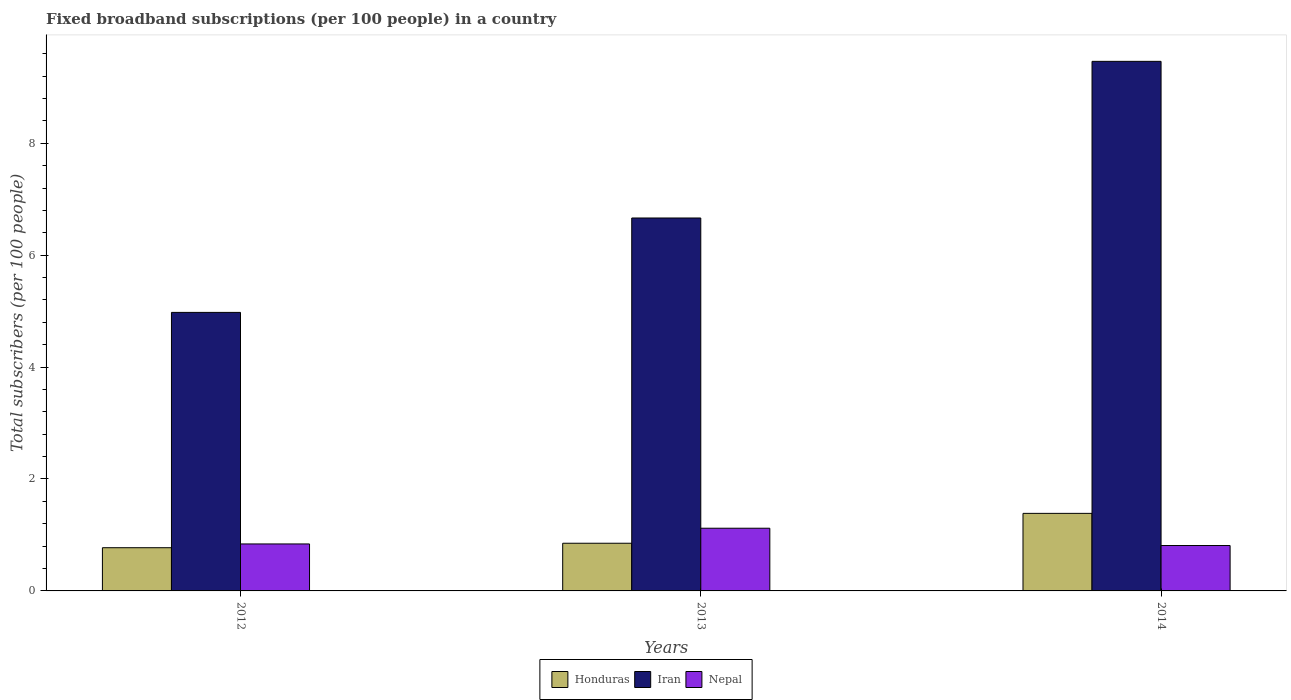How many groups of bars are there?
Offer a very short reply. 3. Are the number of bars per tick equal to the number of legend labels?
Your answer should be compact. Yes. Are the number of bars on each tick of the X-axis equal?
Your response must be concise. Yes. In how many cases, is the number of bars for a given year not equal to the number of legend labels?
Your answer should be compact. 0. What is the number of broadband subscriptions in Honduras in 2012?
Your answer should be compact. 0.77. Across all years, what is the maximum number of broadband subscriptions in Nepal?
Offer a very short reply. 1.12. Across all years, what is the minimum number of broadband subscriptions in Nepal?
Offer a very short reply. 0.81. In which year was the number of broadband subscriptions in Iran minimum?
Provide a succinct answer. 2012. What is the total number of broadband subscriptions in Honduras in the graph?
Your response must be concise. 3.01. What is the difference between the number of broadband subscriptions in Nepal in 2013 and that in 2014?
Offer a very short reply. 0.31. What is the difference between the number of broadband subscriptions in Nepal in 2014 and the number of broadband subscriptions in Honduras in 2013?
Offer a very short reply. -0.04. What is the average number of broadband subscriptions in Iran per year?
Make the answer very short. 7.03. In the year 2014, what is the difference between the number of broadband subscriptions in Honduras and number of broadband subscriptions in Iran?
Ensure brevity in your answer.  -8.08. What is the ratio of the number of broadband subscriptions in Nepal in 2012 to that in 2014?
Your answer should be compact. 1.03. Is the difference between the number of broadband subscriptions in Honduras in 2012 and 2014 greater than the difference between the number of broadband subscriptions in Iran in 2012 and 2014?
Your answer should be compact. Yes. What is the difference between the highest and the second highest number of broadband subscriptions in Iran?
Offer a terse response. 2.8. What is the difference between the highest and the lowest number of broadband subscriptions in Nepal?
Give a very brief answer. 0.31. In how many years, is the number of broadband subscriptions in Iran greater than the average number of broadband subscriptions in Iran taken over all years?
Give a very brief answer. 1. What does the 1st bar from the left in 2012 represents?
Your answer should be very brief. Honduras. What does the 2nd bar from the right in 2012 represents?
Make the answer very short. Iran. Is it the case that in every year, the sum of the number of broadband subscriptions in Nepal and number of broadband subscriptions in Iran is greater than the number of broadband subscriptions in Honduras?
Ensure brevity in your answer.  Yes. Are the values on the major ticks of Y-axis written in scientific E-notation?
Give a very brief answer. No. Does the graph contain any zero values?
Your response must be concise. No. How many legend labels are there?
Your response must be concise. 3. How are the legend labels stacked?
Your response must be concise. Horizontal. What is the title of the graph?
Your answer should be compact. Fixed broadband subscriptions (per 100 people) in a country. What is the label or title of the X-axis?
Your response must be concise. Years. What is the label or title of the Y-axis?
Give a very brief answer. Total subscribers (per 100 people). What is the Total subscribers (per 100 people) in Honduras in 2012?
Provide a succinct answer. 0.77. What is the Total subscribers (per 100 people) in Iran in 2012?
Provide a short and direct response. 4.98. What is the Total subscribers (per 100 people) of Nepal in 2012?
Your response must be concise. 0.84. What is the Total subscribers (per 100 people) in Honduras in 2013?
Give a very brief answer. 0.85. What is the Total subscribers (per 100 people) in Iran in 2013?
Your answer should be compact. 6.66. What is the Total subscribers (per 100 people) in Nepal in 2013?
Your answer should be compact. 1.12. What is the Total subscribers (per 100 people) in Honduras in 2014?
Give a very brief answer. 1.39. What is the Total subscribers (per 100 people) in Iran in 2014?
Offer a terse response. 9.46. What is the Total subscribers (per 100 people) of Nepal in 2014?
Your answer should be very brief. 0.81. Across all years, what is the maximum Total subscribers (per 100 people) in Honduras?
Your answer should be compact. 1.39. Across all years, what is the maximum Total subscribers (per 100 people) of Iran?
Your answer should be compact. 9.46. Across all years, what is the maximum Total subscribers (per 100 people) of Nepal?
Offer a terse response. 1.12. Across all years, what is the minimum Total subscribers (per 100 people) of Honduras?
Ensure brevity in your answer.  0.77. Across all years, what is the minimum Total subscribers (per 100 people) in Iran?
Your response must be concise. 4.98. Across all years, what is the minimum Total subscribers (per 100 people) of Nepal?
Provide a short and direct response. 0.81. What is the total Total subscribers (per 100 people) of Honduras in the graph?
Offer a terse response. 3.01. What is the total Total subscribers (per 100 people) in Iran in the graph?
Keep it short and to the point. 21.1. What is the total Total subscribers (per 100 people) in Nepal in the graph?
Keep it short and to the point. 2.77. What is the difference between the Total subscribers (per 100 people) in Honduras in 2012 and that in 2013?
Keep it short and to the point. -0.08. What is the difference between the Total subscribers (per 100 people) of Iran in 2012 and that in 2013?
Your answer should be very brief. -1.69. What is the difference between the Total subscribers (per 100 people) in Nepal in 2012 and that in 2013?
Provide a short and direct response. -0.28. What is the difference between the Total subscribers (per 100 people) of Honduras in 2012 and that in 2014?
Your answer should be very brief. -0.61. What is the difference between the Total subscribers (per 100 people) of Iran in 2012 and that in 2014?
Ensure brevity in your answer.  -4.49. What is the difference between the Total subscribers (per 100 people) of Nepal in 2012 and that in 2014?
Provide a succinct answer. 0.03. What is the difference between the Total subscribers (per 100 people) in Honduras in 2013 and that in 2014?
Your answer should be compact. -0.53. What is the difference between the Total subscribers (per 100 people) in Iran in 2013 and that in 2014?
Provide a short and direct response. -2.8. What is the difference between the Total subscribers (per 100 people) of Nepal in 2013 and that in 2014?
Make the answer very short. 0.31. What is the difference between the Total subscribers (per 100 people) in Honduras in 2012 and the Total subscribers (per 100 people) in Iran in 2013?
Provide a succinct answer. -5.89. What is the difference between the Total subscribers (per 100 people) in Honduras in 2012 and the Total subscribers (per 100 people) in Nepal in 2013?
Your answer should be very brief. -0.35. What is the difference between the Total subscribers (per 100 people) in Iran in 2012 and the Total subscribers (per 100 people) in Nepal in 2013?
Give a very brief answer. 3.86. What is the difference between the Total subscribers (per 100 people) in Honduras in 2012 and the Total subscribers (per 100 people) in Iran in 2014?
Your response must be concise. -8.69. What is the difference between the Total subscribers (per 100 people) in Honduras in 2012 and the Total subscribers (per 100 people) in Nepal in 2014?
Provide a short and direct response. -0.04. What is the difference between the Total subscribers (per 100 people) in Iran in 2012 and the Total subscribers (per 100 people) in Nepal in 2014?
Make the answer very short. 4.17. What is the difference between the Total subscribers (per 100 people) in Honduras in 2013 and the Total subscribers (per 100 people) in Iran in 2014?
Ensure brevity in your answer.  -8.61. What is the difference between the Total subscribers (per 100 people) in Honduras in 2013 and the Total subscribers (per 100 people) in Nepal in 2014?
Give a very brief answer. 0.04. What is the difference between the Total subscribers (per 100 people) in Iran in 2013 and the Total subscribers (per 100 people) in Nepal in 2014?
Your answer should be very brief. 5.85. What is the average Total subscribers (per 100 people) in Honduras per year?
Offer a terse response. 1. What is the average Total subscribers (per 100 people) in Iran per year?
Your answer should be compact. 7.03. What is the average Total subscribers (per 100 people) in Nepal per year?
Your answer should be very brief. 0.92. In the year 2012, what is the difference between the Total subscribers (per 100 people) in Honduras and Total subscribers (per 100 people) in Iran?
Ensure brevity in your answer.  -4.2. In the year 2012, what is the difference between the Total subscribers (per 100 people) in Honduras and Total subscribers (per 100 people) in Nepal?
Your answer should be very brief. -0.07. In the year 2012, what is the difference between the Total subscribers (per 100 people) in Iran and Total subscribers (per 100 people) in Nepal?
Make the answer very short. 4.14. In the year 2013, what is the difference between the Total subscribers (per 100 people) of Honduras and Total subscribers (per 100 people) of Iran?
Your answer should be very brief. -5.81. In the year 2013, what is the difference between the Total subscribers (per 100 people) in Honduras and Total subscribers (per 100 people) in Nepal?
Give a very brief answer. -0.27. In the year 2013, what is the difference between the Total subscribers (per 100 people) of Iran and Total subscribers (per 100 people) of Nepal?
Give a very brief answer. 5.54. In the year 2014, what is the difference between the Total subscribers (per 100 people) in Honduras and Total subscribers (per 100 people) in Iran?
Keep it short and to the point. -8.08. In the year 2014, what is the difference between the Total subscribers (per 100 people) of Honduras and Total subscribers (per 100 people) of Nepal?
Offer a terse response. 0.57. In the year 2014, what is the difference between the Total subscribers (per 100 people) in Iran and Total subscribers (per 100 people) in Nepal?
Offer a very short reply. 8.65. What is the ratio of the Total subscribers (per 100 people) of Honduras in 2012 to that in 2013?
Your response must be concise. 0.91. What is the ratio of the Total subscribers (per 100 people) in Iran in 2012 to that in 2013?
Make the answer very short. 0.75. What is the ratio of the Total subscribers (per 100 people) in Nepal in 2012 to that in 2013?
Offer a terse response. 0.75. What is the ratio of the Total subscribers (per 100 people) of Honduras in 2012 to that in 2014?
Give a very brief answer. 0.56. What is the ratio of the Total subscribers (per 100 people) of Iran in 2012 to that in 2014?
Offer a very short reply. 0.53. What is the ratio of the Total subscribers (per 100 people) of Nepal in 2012 to that in 2014?
Offer a very short reply. 1.03. What is the ratio of the Total subscribers (per 100 people) of Honduras in 2013 to that in 2014?
Your answer should be compact. 0.61. What is the ratio of the Total subscribers (per 100 people) in Iran in 2013 to that in 2014?
Your answer should be very brief. 0.7. What is the ratio of the Total subscribers (per 100 people) of Nepal in 2013 to that in 2014?
Provide a short and direct response. 1.38. What is the difference between the highest and the second highest Total subscribers (per 100 people) in Honduras?
Make the answer very short. 0.53. What is the difference between the highest and the second highest Total subscribers (per 100 people) of Iran?
Your answer should be compact. 2.8. What is the difference between the highest and the second highest Total subscribers (per 100 people) in Nepal?
Make the answer very short. 0.28. What is the difference between the highest and the lowest Total subscribers (per 100 people) of Honduras?
Offer a terse response. 0.61. What is the difference between the highest and the lowest Total subscribers (per 100 people) in Iran?
Make the answer very short. 4.49. What is the difference between the highest and the lowest Total subscribers (per 100 people) in Nepal?
Provide a succinct answer. 0.31. 